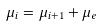Convert formula to latex. <formula><loc_0><loc_0><loc_500><loc_500>\mu _ { i } = \mu _ { i + 1 } + \mu _ { e }</formula> 